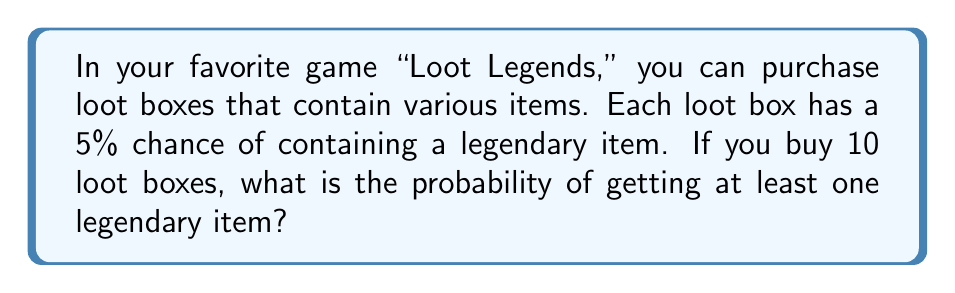Can you answer this question? Let's approach this step-by-step:

1) First, let's consider the probability of not getting a legendary item in a single loot box. If the probability of getting a legendary item is 5% or 0.05, then the probability of not getting one is:

   $1 - 0.05 = 0.95$ or 95%

2) Now, for 10 loot boxes, we want to calculate the probability of not getting any legendary items. This would mean failing to get a legendary item 10 times in a row. We can calculate this as:

   $0.95^{10} \approx 0.5987$

3) This 0.5987 represents the probability of getting no legendary items in 10 loot boxes. However, the question asks for the probability of getting at least one legendary item.

4) The probability of getting at least one legendary item is the opposite of getting no legendary items. We can calculate this as:

   $1 - 0.5987 \approx 0.4013$

5) Converting to a percentage:

   $0.4013 \times 100\% \approx 40.13\%$

Therefore, the probability of getting at least one legendary item in 10 loot boxes is approximately 40.13%.
Answer: 40.13% 